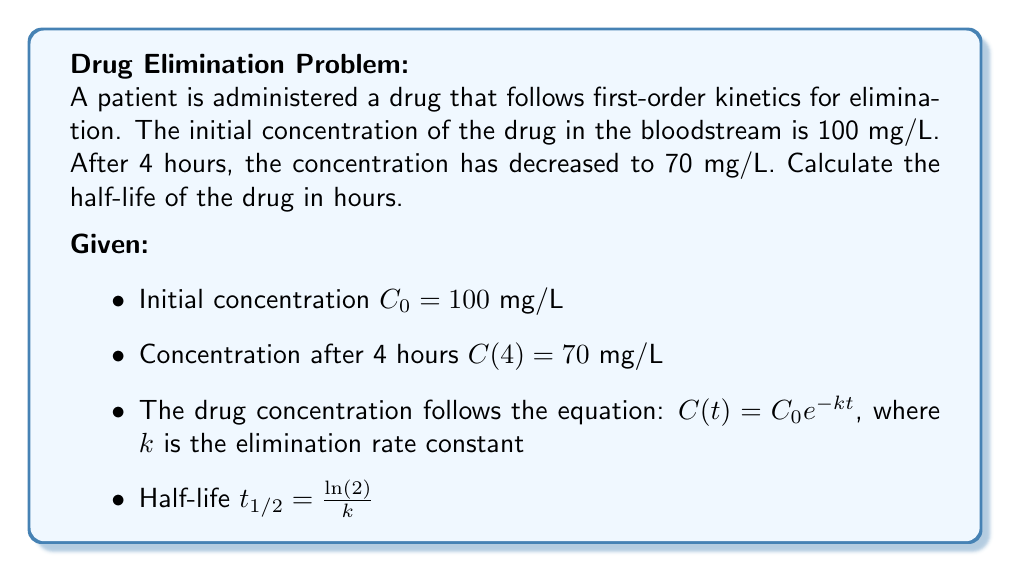Can you solve this math problem? Let's approach this step-by-step:

1) We know that $C(t) = C_0 e^{-kt}$. Let's use the given information to find $k$.

2) After 4 hours, $C(4) = 70$ mg/L. We can write:
   
   $70 = 100 e^{-4k}$

3) Divide both sides by 100:
   
   $0.7 = e^{-4k}$

4) Take the natural log of both sides:
   
   $\ln(0.7) = -4k$

5) Solve for $k$:
   
   $k = -\frac{\ln(0.7)}{4} \approx 0.0892$ hour$^{-1}$

6) Now that we have $k$, we can use the half-life formula:

   $t_{1/2} = \frac{\ln(2)}{k}$

7) Substitute the value of $k$:
   
   $t_{1/2} = \frac{\ln(2)}{0.0892} \approx 7.77$ hours

Therefore, the half-life of the drug is approximately 7.77 hours.
Answer: 7.77 hours 